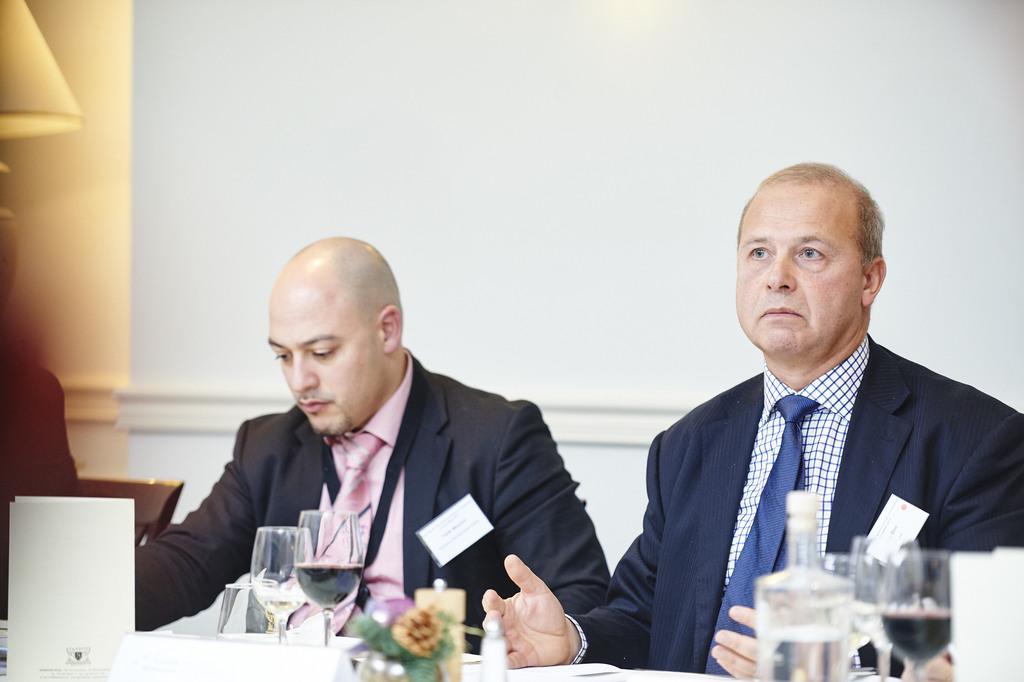Can you describe this image briefly? Here I can see two men wearing suits, sitting in front of a table. On the table I can see few glasses, bottle, flowers, papers and some other objects. On the left side there is another person sitting on the chair. In the background there is a wall. In the top left there is a lamp. 